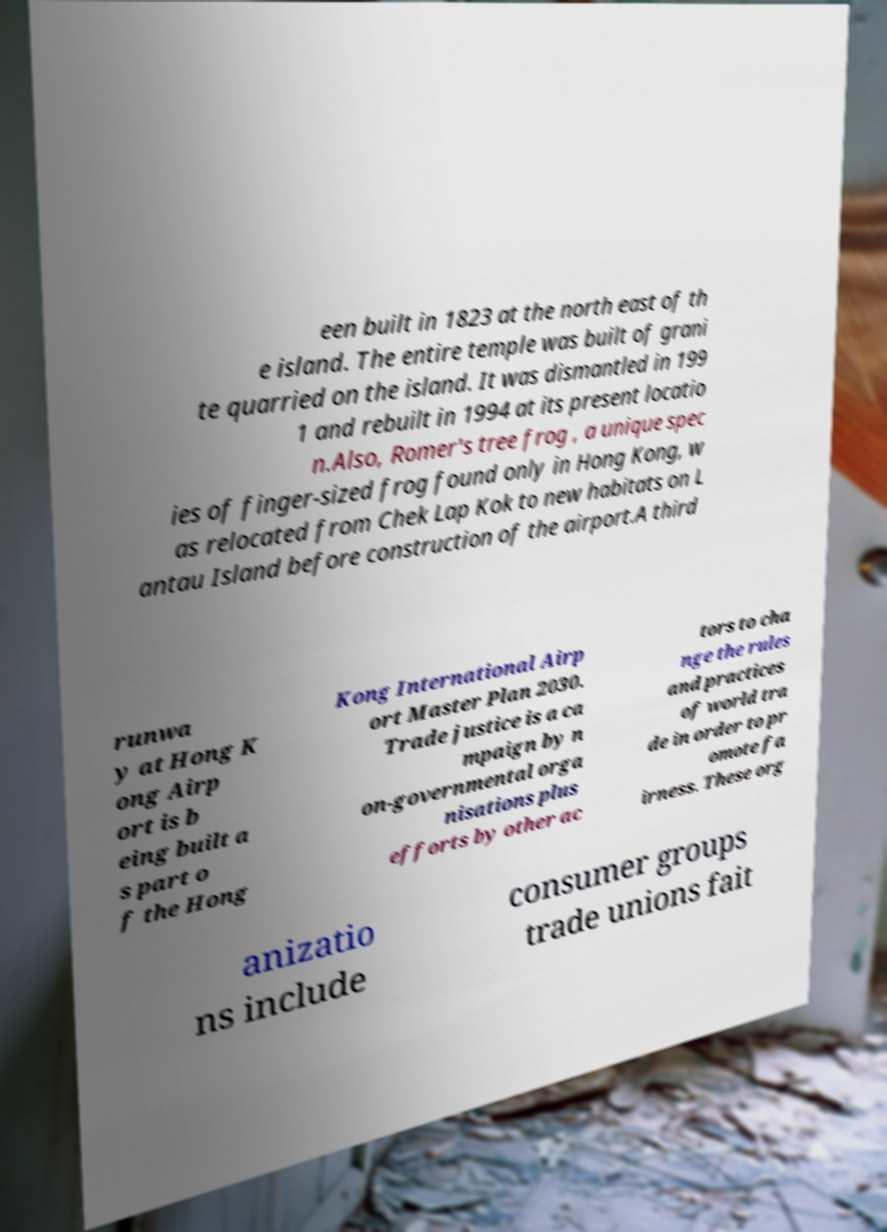Could you assist in decoding the text presented in this image and type it out clearly? een built in 1823 at the north east of th e island. The entire temple was built of grani te quarried on the island. It was dismantled in 199 1 and rebuilt in 1994 at its present locatio n.Also, Romer's tree frog , a unique spec ies of finger-sized frog found only in Hong Kong, w as relocated from Chek Lap Kok to new habitats on L antau Island before construction of the airport.A third runwa y at Hong K ong Airp ort is b eing built a s part o f the Hong Kong International Airp ort Master Plan 2030. Trade justice is a ca mpaign by n on-governmental orga nisations plus efforts by other ac tors to cha nge the rules and practices of world tra de in order to pr omote fa irness. These org anizatio ns include consumer groups trade unions fait 